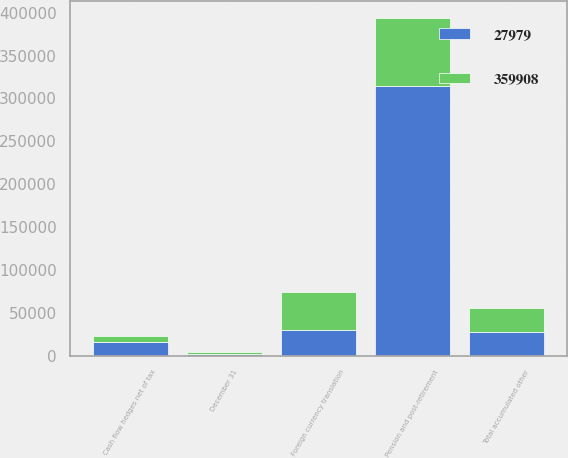<chart> <loc_0><loc_0><loc_500><loc_500><stacked_bar_chart><ecel><fcel>December 31<fcel>Foreign currency translation<fcel>Pension and post-retirement<fcel>Cash flow hedges net of tax<fcel>Total accumulated other<nl><fcel>27979<fcel>2008<fcel>29753<fcel>314353<fcel>15802<fcel>27979<nl><fcel>359908<fcel>2007<fcel>44810<fcel>79565<fcel>6776<fcel>27979<nl></chart> 